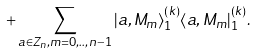<formula> <loc_0><loc_0><loc_500><loc_500>+ \sum _ { a \in Z _ { n } , m = 0 , . . , n - 1 } | a , M _ { m } \rangle ^ { ( k ) } _ { 1 } \langle a , M _ { m } | ^ { ( k ) } _ { 1 } .</formula> 